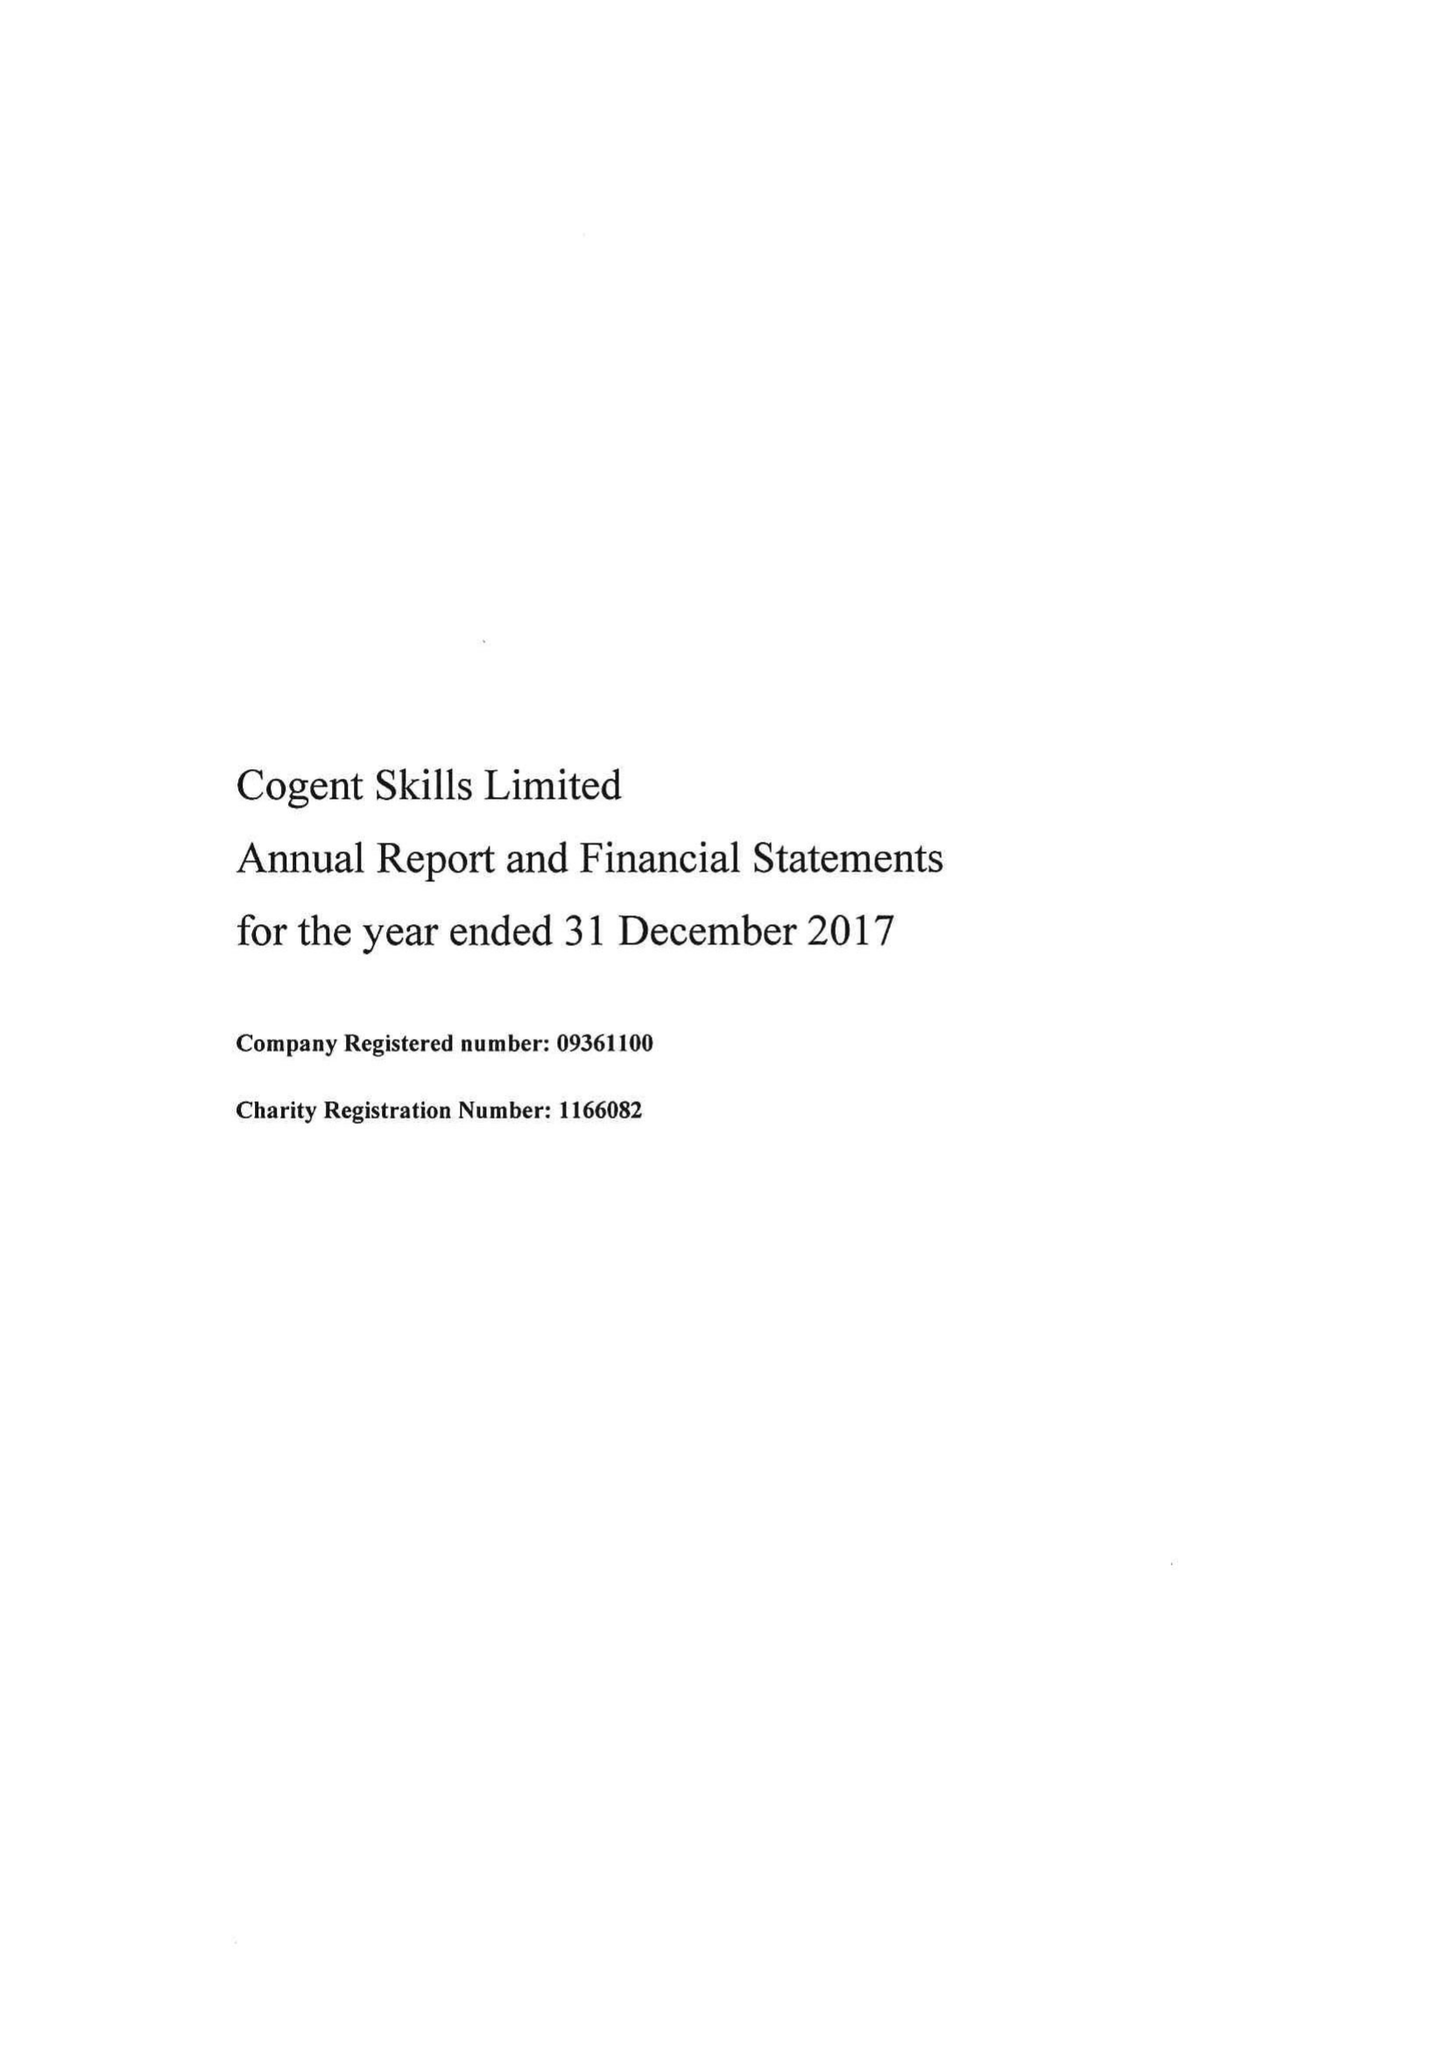What is the value for the charity_name?
Answer the question using a single word or phrase. Cogent Skills Ltd. 